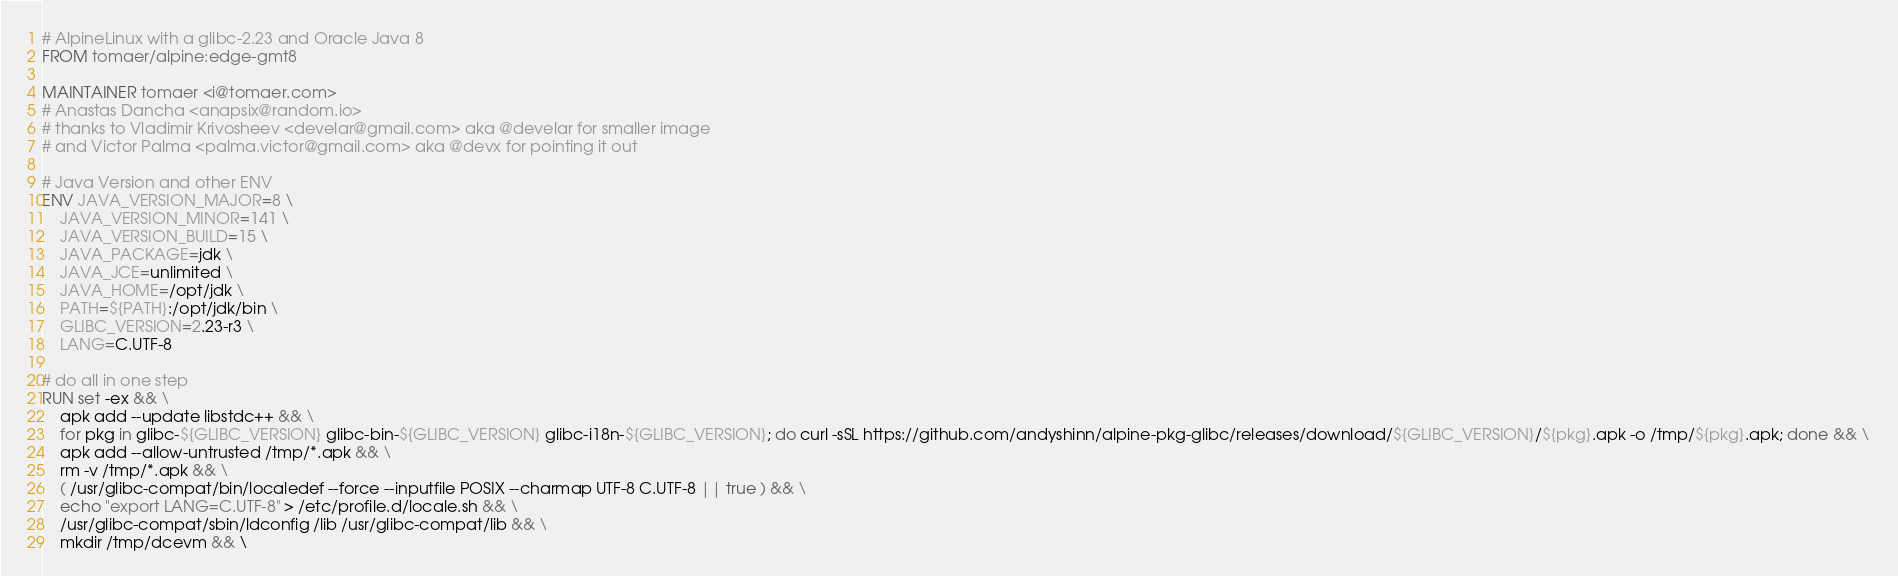Convert code to text. <code><loc_0><loc_0><loc_500><loc_500><_Dockerfile_># AlpineLinux with a glibc-2.23 and Oracle Java 8
FROM tomaer/alpine:edge-gmt8

MAINTAINER tomaer <i@tomaer.com>
# Anastas Dancha <anapsix@random.io>
# thanks to Vladimir Krivosheev <develar@gmail.com> aka @develar for smaller image
# and Victor Palma <palma.victor@gmail.com> aka @devx for pointing it out

# Java Version and other ENV
ENV JAVA_VERSION_MAJOR=8 \
    JAVA_VERSION_MINOR=141 \
    JAVA_VERSION_BUILD=15 \
    JAVA_PACKAGE=jdk \
    JAVA_JCE=unlimited \
    JAVA_HOME=/opt/jdk \
    PATH=${PATH}:/opt/jdk/bin \
    GLIBC_VERSION=2.23-r3 \
    LANG=C.UTF-8

# do all in one step
RUN set -ex && \
    apk add --update libstdc++ && \
    for pkg in glibc-${GLIBC_VERSION} glibc-bin-${GLIBC_VERSION} glibc-i18n-${GLIBC_VERSION}; do curl -sSL https://github.com/andyshinn/alpine-pkg-glibc/releases/download/${GLIBC_VERSION}/${pkg}.apk -o /tmp/${pkg}.apk; done && \
    apk add --allow-untrusted /tmp/*.apk && \
    rm -v /tmp/*.apk && \
    ( /usr/glibc-compat/bin/localedef --force --inputfile POSIX --charmap UTF-8 C.UTF-8 || true ) && \
    echo "export LANG=C.UTF-8" > /etc/profile.d/locale.sh && \
    /usr/glibc-compat/sbin/ldconfig /lib /usr/glibc-compat/lib && \
    mkdir /tmp/dcevm && \</code> 